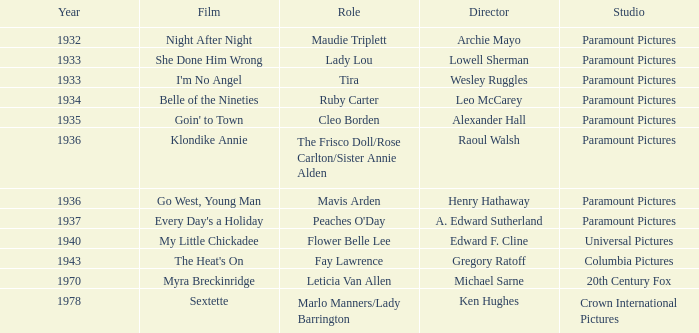In which year was the movie klondike annie released? 1936.0. 